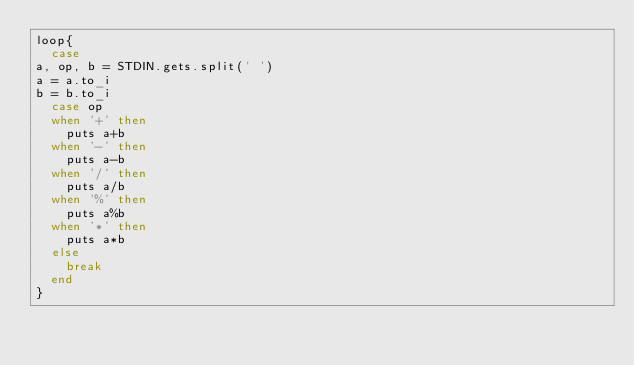Convert code to text. <code><loc_0><loc_0><loc_500><loc_500><_Ruby_>loop{
  case 
a, op, b = STDIN.gets.split(' ')
a = a.to_i
b = b.to_i
  case op
  when '+' then
    puts a+b
  when '-' then
    puts a-b
  when '/' then
    puts a/b
  when '%' then
    puts a%b
  when '*' then
    puts a*b
  else
    break
  end
}</code> 